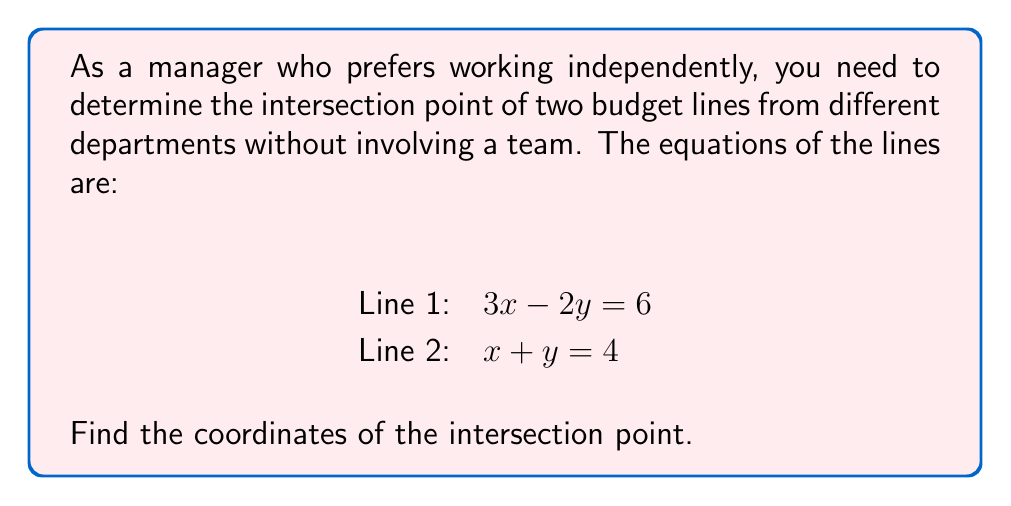Could you help me with this problem? To find the intersection point of two lines, we need to solve the system of equations:

$$\begin{cases}
3x - 2y = 6 \\
x + y = 4
\end{cases}$$

Step 1: Isolate y in the second equation
$x + y = 4$
$y = 4 - x$

Step 2: Substitute y in the first equation
$3x - 2(4 - x) = 6$

Step 3: Simplify
$3x - 8 + 2x = 6$
$5x - 8 = 6$

Step 4: Solve for x
$5x = 14$
$x = \frac{14}{5} = 2.8$

Step 5: Find y by substituting x in either original equation
Using $x + y = 4$:
$2.8 + y = 4$
$y = 4 - 2.8 = 1.2$

Therefore, the intersection point is (2.8, 1.2).
Answer: (2.8, 1.2) 